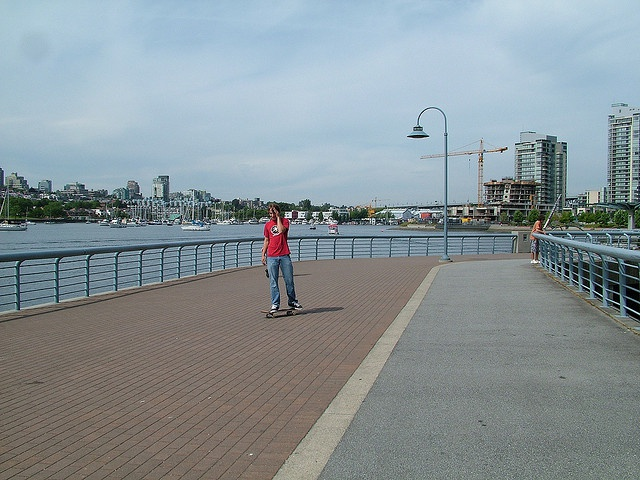Describe the objects in this image and their specific colors. I can see people in lightblue, black, gray, and blue tones, boat in lightblue, gray, darkgray, lightgray, and black tones, people in lightblue, black, gray, darkgray, and maroon tones, boat in lightblue, gray, black, and darkgray tones, and skateboard in lightblue, black, gray, and darkgray tones in this image. 